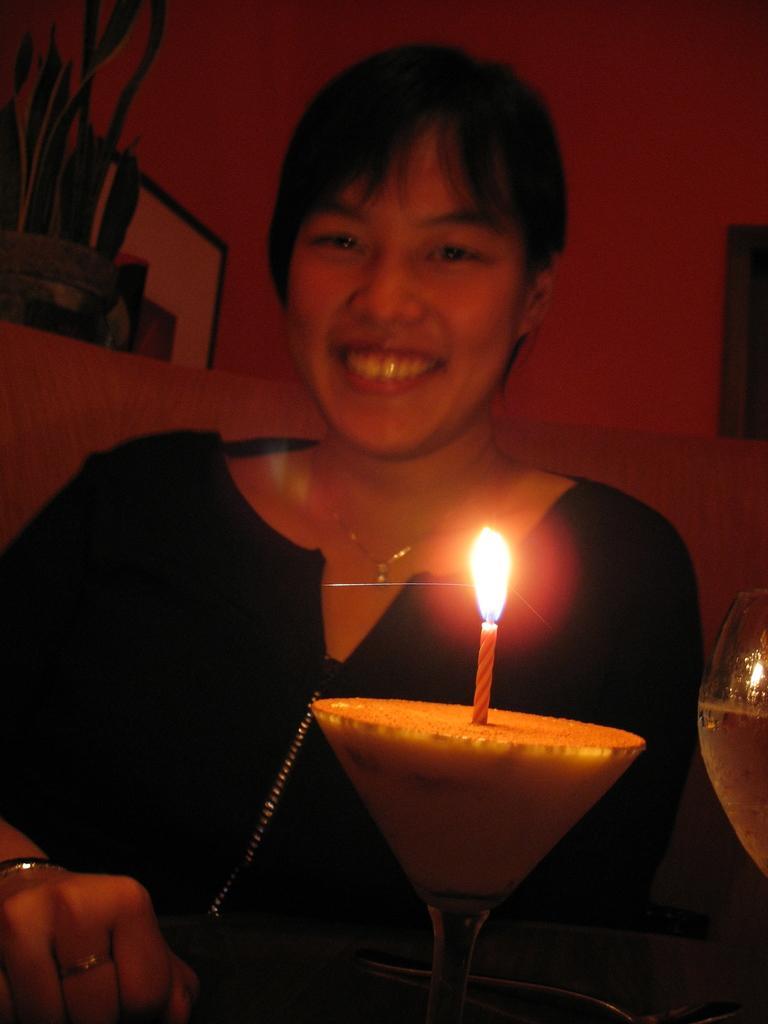Can you describe this image briefly? In this image, we can see a lady smiling and we can see a candle, which is lifted and placed on the glass and there is an other glass with drink. In the background, there are some boards and we can see a wall. 